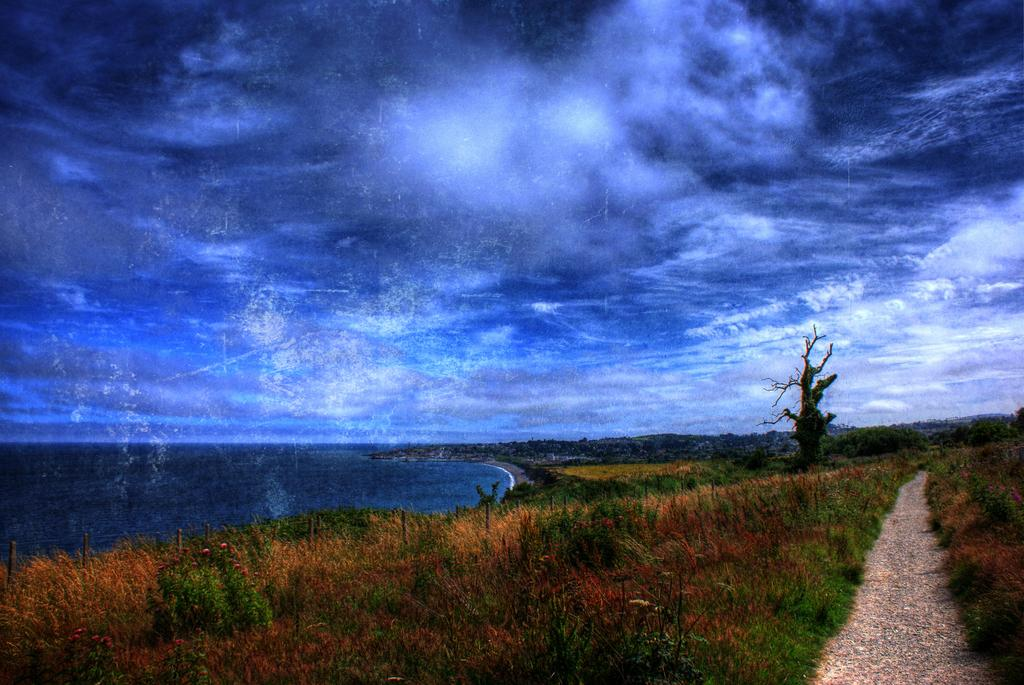What type of body of water is present in the image? There is a pond in the image. What is the condition of the sky in the image? The sky appears to be cloudy in the image. What type of vegetation can be seen in the image? Grass is visible in the image. What type of man-made structure can be seen in the image? There is a road in the image. Is there a sink visible in the image? No, there is no sink present in the image. Is anyone using an umbrella in the image? There is no umbrella present in the image. 